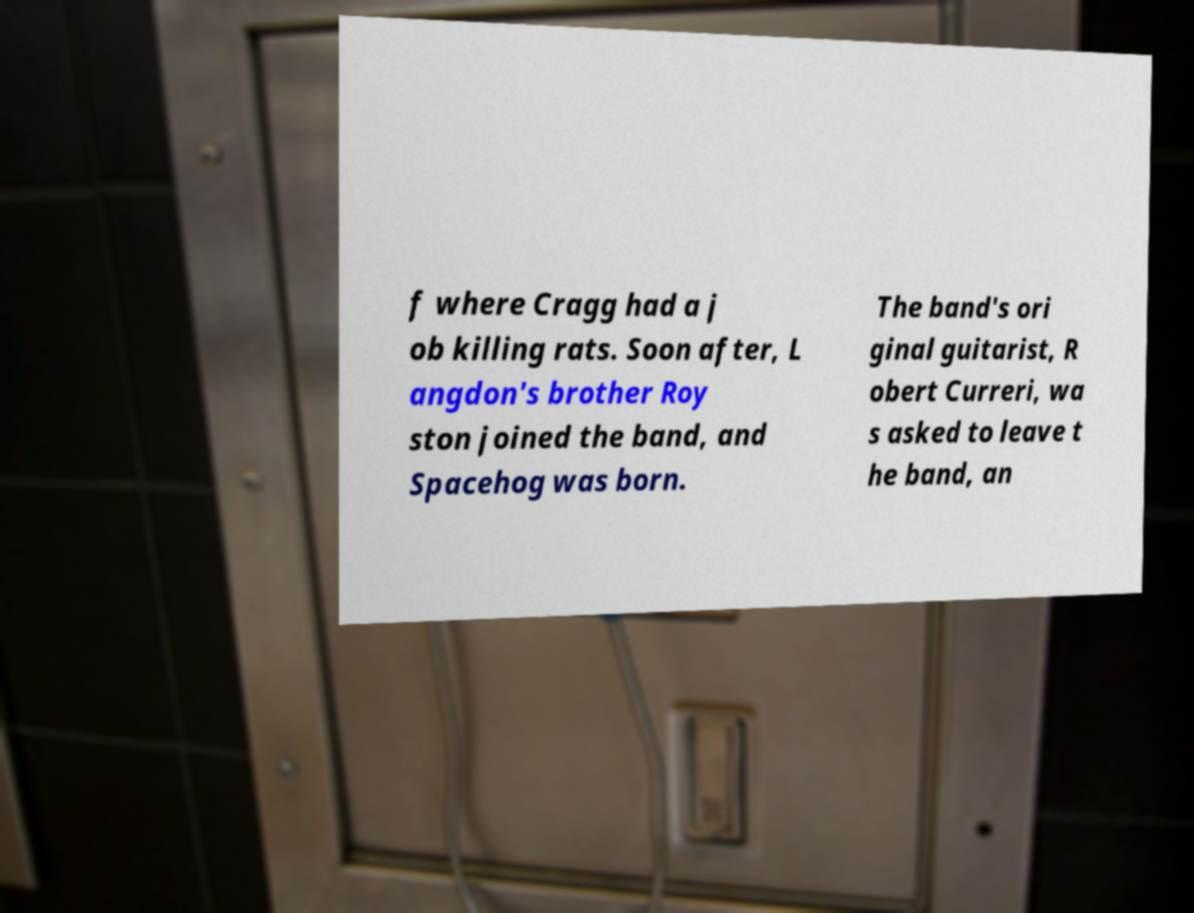For documentation purposes, I need the text within this image transcribed. Could you provide that? f where Cragg had a j ob killing rats. Soon after, L angdon's brother Roy ston joined the band, and Spacehog was born. The band's ori ginal guitarist, R obert Curreri, wa s asked to leave t he band, an 